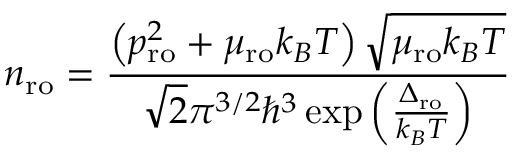Convert formula to latex. <formula><loc_0><loc_0><loc_500><loc_500>n _ { r o } = \frac { \left ( p _ { r o } ^ { 2 } + \mu _ { r o } k _ { B } T \right ) \sqrt { \mu _ { r o } k _ { B } T } } { \sqrt { 2 } \pi ^ { 3 / 2 } \hbar { ^ } { 3 } \exp \left ( \frac { \Delta _ { r o } } { k _ { B } T } \right ) }</formula> 